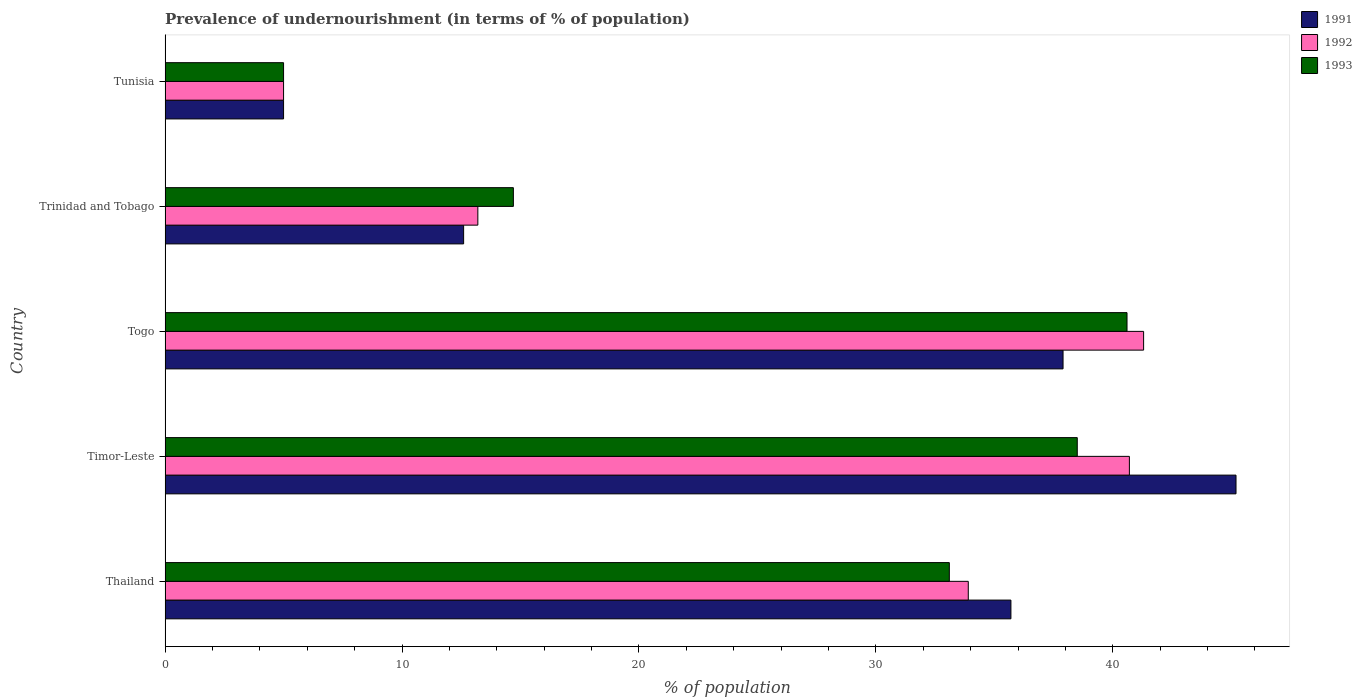Are the number of bars per tick equal to the number of legend labels?
Your answer should be very brief. Yes. What is the label of the 2nd group of bars from the top?
Your answer should be very brief. Trinidad and Tobago. In how many cases, is the number of bars for a given country not equal to the number of legend labels?
Keep it short and to the point. 0. What is the percentage of undernourished population in 1993 in Tunisia?
Offer a very short reply. 5. Across all countries, what is the maximum percentage of undernourished population in 1993?
Your answer should be compact. 40.6. Across all countries, what is the minimum percentage of undernourished population in 1991?
Keep it short and to the point. 5. In which country was the percentage of undernourished population in 1992 maximum?
Make the answer very short. Togo. In which country was the percentage of undernourished population in 1992 minimum?
Ensure brevity in your answer.  Tunisia. What is the total percentage of undernourished population in 1991 in the graph?
Offer a terse response. 136.4. What is the difference between the percentage of undernourished population in 1992 in Timor-Leste and that in Trinidad and Tobago?
Give a very brief answer. 27.5. What is the difference between the percentage of undernourished population in 1992 in Thailand and the percentage of undernourished population in 1993 in Togo?
Your answer should be compact. -6.7. What is the average percentage of undernourished population in 1992 per country?
Your answer should be very brief. 26.82. What is the difference between the percentage of undernourished population in 1992 and percentage of undernourished population in 1991 in Thailand?
Your response must be concise. -1.8. What is the ratio of the percentage of undernourished population in 1991 in Timor-Leste to that in Tunisia?
Your answer should be compact. 9.04. What is the difference between the highest and the second highest percentage of undernourished population in 1993?
Provide a succinct answer. 2.1. What is the difference between the highest and the lowest percentage of undernourished population in 1993?
Provide a succinct answer. 35.6. Is the sum of the percentage of undernourished population in 1992 in Timor-Leste and Tunisia greater than the maximum percentage of undernourished population in 1991 across all countries?
Your answer should be very brief. Yes. What does the 2nd bar from the top in Tunisia represents?
Your response must be concise. 1992. What does the 1st bar from the bottom in Timor-Leste represents?
Provide a short and direct response. 1991. Is it the case that in every country, the sum of the percentage of undernourished population in 1991 and percentage of undernourished population in 1993 is greater than the percentage of undernourished population in 1992?
Keep it short and to the point. Yes. How many bars are there?
Provide a short and direct response. 15. Are all the bars in the graph horizontal?
Your answer should be compact. Yes. How many countries are there in the graph?
Make the answer very short. 5. Are the values on the major ticks of X-axis written in scientific E-notation?
Provide a short and direct response. No. How many legend labels are there?
Provide a succinct answer. 3. What is the title of the graph?
Give a very brief answer. Prevalence of undernourishment (in terms of % of population). Does "1983" appear as one of the legend labels in the graph?
Provide a short and direct response. No. What is the label or title of the X-axis?
Offer a terse response. % of population. What is the % of population of 1991 in Thailand?
Offer a very short reply. 35.7. What is the % of population of 1992 in Thailand?
Ensure brevity in your answer.  33.9. What is the % of population of 1993 in Thailand?
Make the answer very short. 33.1. What is the % of population of 1991 in Timor-Leste?
Offer a terse response. 45.2. What is the % of population in 1992 in Timor-Leste?
Provide a short and direct response. 40.7. What is the % of population of 1993 in Timor-Leste?
Give a very brief answer. 38.5. What is the % of population of 1991 in Togo?
Your answer should be very brief. 37.9. What is the % of population of 1992 in Togo?
Keep it short and to the point. 41.3. What is the % of population in 1993 in Togo?
Offer a terse response. 40.6. What is the % of population of 1991 in Trinidad and Tobago?
Your response must be concise. 12.6. What is the % of population in 1992 in Trinidad and Tobago?
Ensure brevity in your answer.  13.2. What is the % of population of 1993 in Trinidad and Tobago?
Offer a very short reply. 14.7. What is the % of population in 1991 in Tunisia?
Give a very brief answer. 5. What is the % of population of 1993 in Tunisia?
Your answer should be compact. 5. Across all countries, what is the maximum % of population of 1991?
Provide a succinct answer. 45.2. Across all countries, what is the maximum % of population in 1992?
Your response must be concise. 41.3. Across all countries, what is the maximum % of population in 1993?
Keep it short and to the point. 40.6. Across all countries, what is the minimum % of population in 1991?
Offer a very short reply. 5. What is the total % of population of 1991 in the graph?
Offer a very short reply. 136.4. What is the total % of population of 1992 in the graph?
Give a very brief answer. 134.1. What is the total % of population in 1993 in the graph?
Your answer should be compact. 131.9. What is the difference between the % of population in 1991 in Thailand and that in Timor-Leste?
Give a very brief answer. -9.5. What is the difference between the % of population in 1992 in Thailand and that in Timor-Leste?
Offer a very short reply. -6.8. What is the difference between the % of population in 1993 in Thailand and that in Timor-Leste?
Ensure brevity in your answer.  -5.4. What is the difference between the % of population in 1991 in Thailand and that in Togo?
Provide a succinct answer. -2.2. What is the difference between the % of population of 1993 in Thailand and that in Togo?
Provide a short and direct response. -7.5. What is the difference between the % of population in 1991 in Thailand and that in Trinidad and Tobago?
Offer a very short reply. 23.1. What is the difference between the % of population in 1992 in Thailand and that in Trinidad and Tobago?
Offer a very short reply. 20.7. What is the difference between the % of population of 1991 in Thailand and that in Tunisia?
Give a very brief answer. 30.7. What is the difference between the % of population of 1992 in Thailand and that in Tunisia?
Give a very brief answer. 28.9. What is the difference between the % of population of 1993 in Thailand and that in Tunisia?
Your answer should be very brief. 28.1. What is the difference between the % of population in 1991 in Timor-Leste and that in Togo?
Offer a very short reply. 7.3. What is the difference between the % of population of 1992 in Timor-Leste and that in Togo?
Your answer should be compact. -0.6. What is the difference between the % of population of 1991 in Timor-Leste and that in Trinidad and Tobago?
Offer a very short reply. 32.6. What is the difference between the % of population of 1992 in Timor-Leste and that in Trinidad and Tobago?
Ensure brevity in your answer.  27.5. What is the difference between the % of population of 1993 in Timor-Leste and that in Trinidad and Tobago?
Make the answer very short. 23.8. What is the difference between the % of population of 1991 in Timor-Leste and that in Tunisia?
Offer a very short reply. 40.2. What is the difference between the % of population of 1992 in Timor-Leste and that in Tunisia?
Offer a terse response. 35.7. What is the difference between the % of population in 1993 in Timor-Leste and that in Tunisia?
Make the answer very short. 33.5. What is the difference between the % of population of 1991 in Togo and that in Trinidad and Tobago?
Offer a terse response. 25.3. What is the difference between the % of population in 1992 in Togo and that in Trinidad and Tobago?
Ensure brevity in your answer.  28.1. What is the difference between the % of population of 1993 in Togo and that in Trinidad and Tobago?
Give a very brief answer. 25.9. What is the difference between the % of population in 1991 in Togo and that in Tunisia?
Your answer should be compact. 32.9. What is the difference between the % of population in 1992 in Togo and that in Tunisia?
Provide a short and direct response. 36.3. What is the difference between the % of population in 1993 in Togo and that in Tunisia?
Your answer should be very brief. 35.6. What is the difference between the % of population of 1991 in Thailand and the % of population of 1992 in Timor-Leste?
Offer a very short reply. -5. What is the difference between the % of population in 1991 in Thailand and the % of population in 1993 in Timor-Leste?
Keep it short and to the point. -2.8. What is the difference between the % of population of 1992 in Thailand and the % of population of 1993 in Timor-Leste?
Keep it short and to the point. -4.6. What is the difference between the % of population of 1991 in Thailand and the % of population of 1992 in Togo?
Provide a succinct answer. -5.6. What is the difference between the % of population in 1991 in Thailand and the % of population in 1993 in Togo?
Your answer should be compact. -4.9. What is the difference between the % of population of 1991 in Thailand and the % of population of 1993 in Trinidad and Tobago?
Provide a succinct answer. 21. What is the difference between the % of population of 1991 in Thailand and the % of population of 1992 in Tunisia?
Your answer should be very brief. 30.7. What is the difference between the % of population in 1991 in Thailand and the % of population in 1993 in Tunisia?
Your answer should be compact. 30.7. What is the difference between the % of population of 1992 in Thailand and the % of population of 1993 in Tunisia?
Ensure brevity in your answer.  28.9. What is the difference between the % of population in 1991 in Timor-Leste and the % of population in 1992 in Togo?
Your answer should be very brief. 3.9. What is the difference between the % of population in 1992 in Timor-Leste and the % of population in 1993 in Togo?
Ensure brevity in your answer.  0.1. What is the difference between the % of population in 1991 in Timor-Leste and the % of population in 1993 in Trinidad and Tobago?
Provide a short and direct response. 30.5. What is the difference between the % of population in 1991 in Timor-Leste and the % of population in 1992 in Tunisia?
Offer a terse response. 40.2. What is the difference between the % of population of 1991 in Timor-Leste and the % of population of 1993 in Tunisia?
Give a very brief answer. 40.2. What is the difference between the % of population of 1992 in Timor-Leste and the % of population of 1993 in Tunisia?
Your answer should be compact. 35.7. What is the difference between the % of population in 1991 in Togo and the % of population in 1992 in Trinidad and Tobago?
Your answer should be compact. 24.7. What is the difference between the % of population of 1991 in Togo and the % of population of 1993 in Trinidad and Tobago?
Offer a very short reply. 23.2. What is the difference between the % of population of 1992 in Togo and the % of population of 1993 in Trinidad and Tobago?
Offer a terse response. 26.6. What is the difference between the % of population of 1991 in Togo and the % of population of 1992 in Tunisia?
Provide a succinct answer. 32.9. What is the difference between the % of population in 1991 in Togo and the % of population in 1993 in Tunisia?
Your response must be concise. 32.9. What is the difference between the % of population in 1992 in Togo and the % of population in 1993 in Tunisia?
Your answer should be compact. 36.3. What is the difference between the % of population in 1991 in Trinidad and Tobago and the % of population in 1992 in Tunisia?
Provide a succinct answer. 7.6. What is the average % of population in 1991 per country?
Offer a terse response. 27.28. What is the average % of population in 1992 per country?
Your response must be concise. 26.82. What is the average % of population in 1993 per country?
Offer a terse response. 26.38. What is the difference between the % of population in 1992 and % of population in 1993 in Timor-Leste?
Offer a very short reply. 2.2. What is the difference between the % of population of 1991 and % of population of 1992 in Togo?
Your response must be concise. -3.4. What is the difference between the % of population in 1991 and % of population in 1992 in Tunisia?
Keep it short and to the point. 0. What is the difference between the % of population of 1991 and % of population of 1993 in Tunisia?
Your answer should be very brief. 0. What is the ratio of the % of population in 1991 in Thailand to that in Timor-Leste?
Offer a very short reply. 0.79. What is the ratio of the % of population of 1992 in Thailand to that in Timor-Leste?
Offer a very short reply. 0.83. What is the ratio of the % of population of 1993 in Thailand to that in Timor-Leste?
Offer a very short reply. 0.86. What is the ratio of the % of population in 1991 in Thailand to that in Togo?
Your answer should be very brief. 0.94. What is the ratio of the % of population in 1992 in Thailand to that in Togo?
Ensure brevity in your answer.  0.82. What is the ratio of the % of population in 1993 in Thailand to that in Togo?
Keep it short and to the point. 0.82. What is the ratio of the % of population of 1991 in Thailand to that in Trinidad and Tobago?
Your response must be concise. 2.83. What is the ratio of the % of population of 1992 in Thailand to that in Trinidad and Tobago?
Provide a short and direct response. 2.57. What is the ratio of the % of population in 1993 in Thailand to that in Trinidad and Tobago?
Make the answer very short. 2.25. What is the ratio of the % of population of 1991 in Thailand to that in Tunisia?
Keep it short and to the point. 7.14. What is the ratio of the % of population in 1992 in Thailand to that in Tunisia?
Your answer should be compact. 6.78. What is the ratio of the % of population in 1993 in Thailand to that in Tunisia?
Provide a short and direct response. 6.62. What is the ratio of the % of population in 1991 in Timor-Leste to that in Togo?
Offer a very short reply. 1.19. What is the ratio of the % of population in 1992 in Timor-Leste to that in Togo?
Offer a terse response. 0.99. What is the ratio of the % of population in 1993 in Timor-Leste to that in Togo?
Make the answer very short. 0.95. What is the ratio of the % of population in 1991 in Timor-Leste to that in Trinidad and Tobago?
Make the answer very short. 3.59. What is the ratio of the % of population in 1992 in Timor-Leste to that in Trinidad and Tobago?
Make the answer very short. 3.08. What is the ratio of the % of population in 1993 in Timor-Leste to that in Trinidad and Tobago?
Make the answer very short. 2.62. What is the ratio of the % of population in 1991 in Timor-Leste to that in Tunisia?
Provide a short and direct response. 9.04. What is the ratio of the % of population of 1992 in Timor-Leste to that in Tunisia?
Ensure brevity in your answer.  8.14. What is the ratio of the % of population of 1991 in Togo to that in Trinidad and Tobago?
Provide a succinct answer. 3.01. What is the ratio of the % of population of 1992 in Togo to that in Trinidad and Tobago?
Your answer should be very brief. 3.13. What is the ratio of the % of population in 1993 in Togo to that in Trinidad and Tobago?
Give a very brief answer. 2.76. What is the ratio of the % of population in 1991 in Togo to that in Tunisia?
Keep it short and to the point. 7.58. What is the ratio of the % of population in 1992 in Togo to that in Tunisia?
Your answer should be very brief. 8.26. What is the ratio of the % of population of 1993 in Togo to that in Tunisia?
Your response must be concise. 8.12. What is the ratio of the % of population in 1991 in Trinidad and Tobago to that in Tunisia?
Provide a short and direct response. 2.52. What is the ratio of the % of population of 1992 in Trinidad and Tobago to that in Tunisia?
Provide a succinct answer. 2.64. What is the ratio of the % of population of 1993 in Trinidad and Tobago to that in Tunisia?
Offer a very short reply. 2.94. What is the difference between the highest and the second highest % of population of 1991?
Give a very brief answer. 7.3. What is the difference between the highest and the lowest % of population in 1991?
Provide a succinct answer. 40.2. What is the difference between the highest and the lowest % of population in 1992?
Your response must be concise. 36.3. What is the difference between the highest and the lowest % of population of 1993?
Provide a short and direct response. 35.6. 